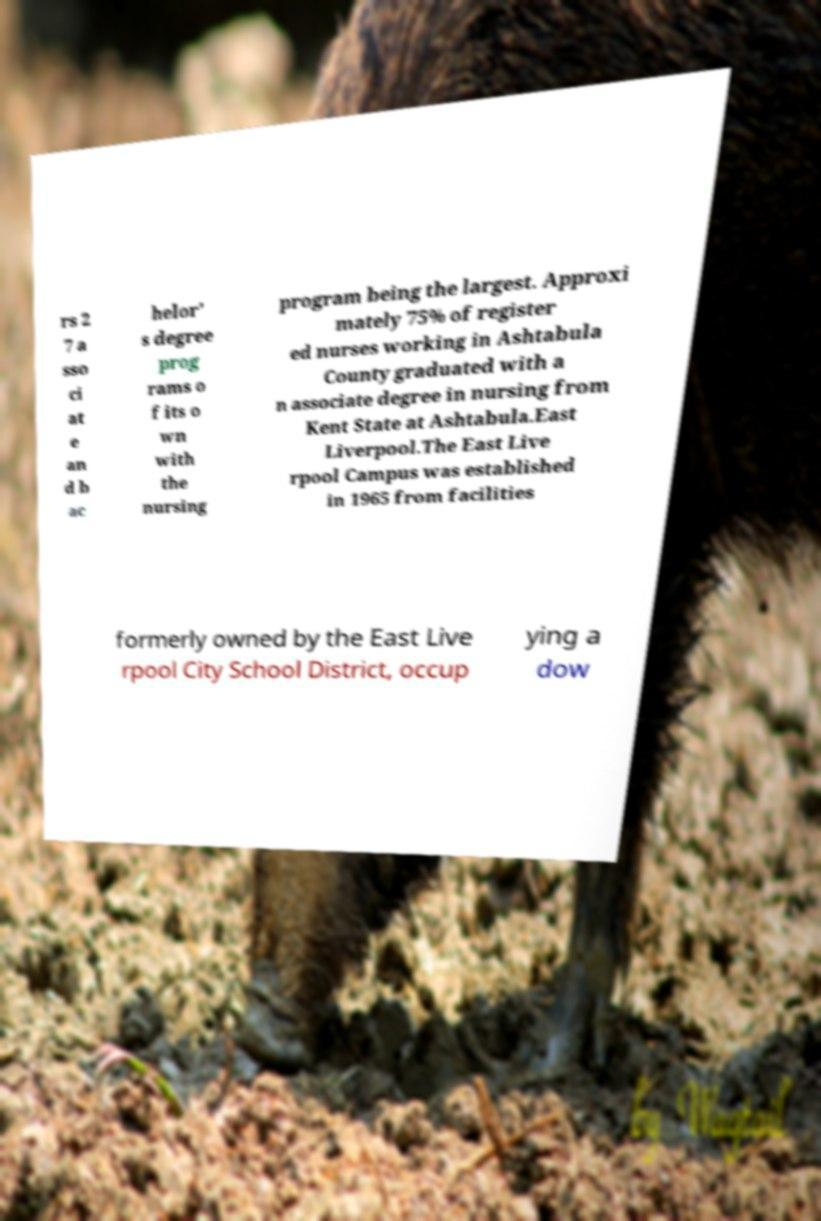Can you read and provide the text displayed in the image?This photo seems to have some interesting text. Can you extract and type it out for me? rs 2 7 a sso ci at e an d b ac helor' s degree prog rams o f its o wn with the nursing program being the largest. Approxi mately 75% of register ed nurses working in Ashtabula County graduated with a n associate degree in nursing from Kent State at Ashtabula.East Liverpool.The East Live rpool Campus was established in 1965 from facilities formerly owned by the East Live rpool City School District, occup ying a dow 